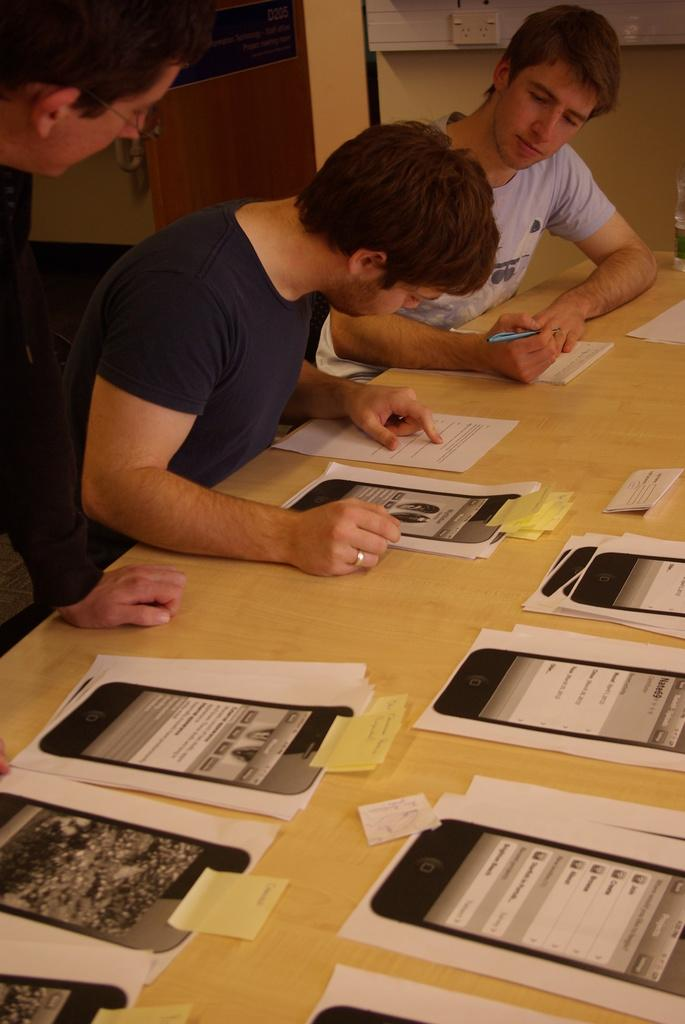How many people are in the image? There is a group of persons in the image. What are two of the persons doing in the image? Two persons are sitting in front of a table. What is the position of one person in the image? One person is standing in the image. What is present on the table in the image? There is a table in the image, and there are papers placed on the table. What type of shirt is the division wearing in the image? There is no division or shirt present in the image. Where is the drawer located in the image? There is no drawer present in the image. 